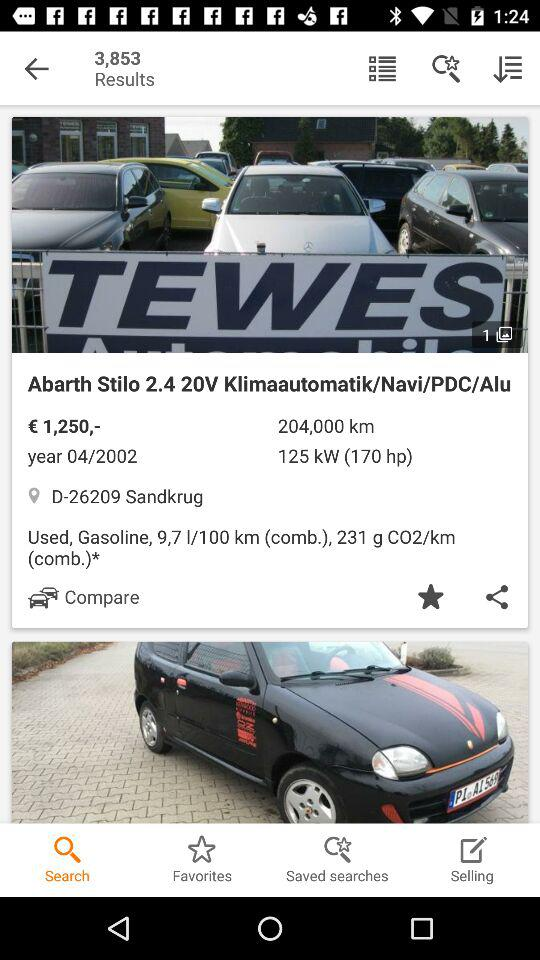What is the consumption of gasoline per 100 kilometers? The consumption of gasoline per 100 kilometers is 9.7 litres. 